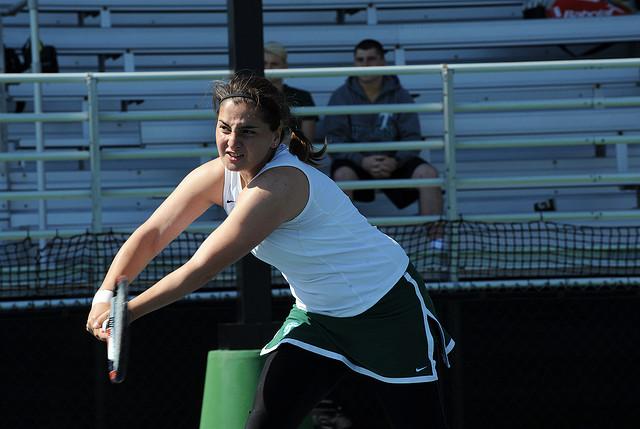What color is her skirt?
Concise answer only. Green. Will she reach the ball?
Keep it brief. Yes. What color is her shirt?
Quick response, please. White. How many legs does the woman have?
Concise answer only. 2. What is the woman holding?
Keep it brief. Tennis racket. 